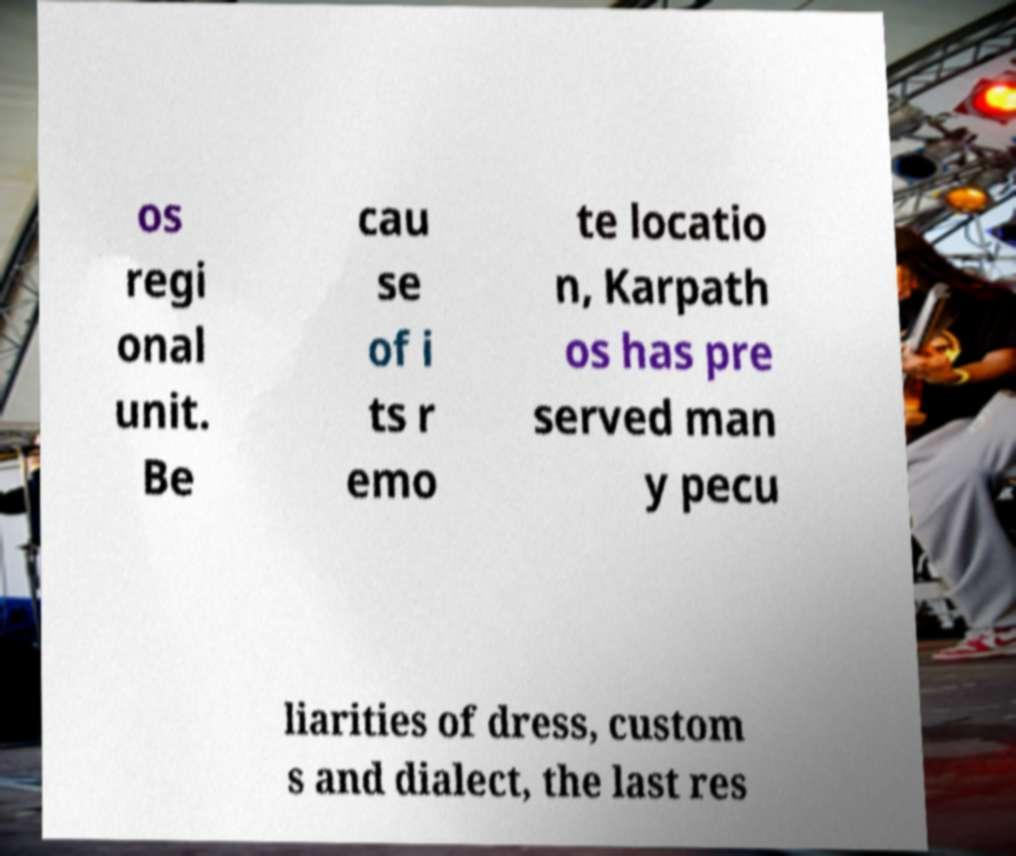Please read and relay the text visible in this image. What does it say? os regi onal unit. Be cau se of i ts r emo te locatio n, Karpath os has pre served man y pecu liarities of dress, custom s and dialect, the last res 